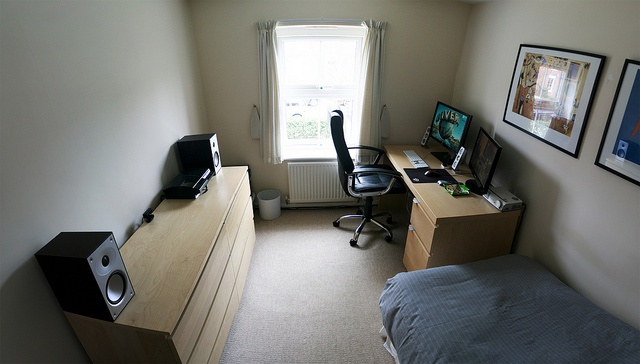Describe the objects in this image and their specific colors. I can see bed in gray, black, and darkblue tones, chair in gray, black, white, and darkgray tones, tv in gray and black tones, tv in gray, black, teal, and darkgreen tones, and keyboard in gray and darkgray tones in this image. 